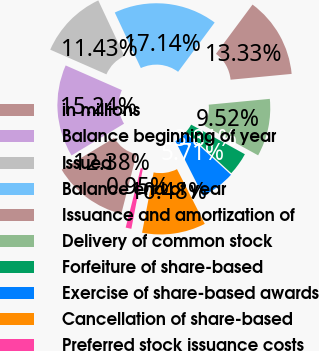Convert chart to OTSL. <chart><loc_0><loc_0><loc_500><loc_500><pie_chart><fcel>in millions<fcel>Balance beginning of year<fcel>Issued<fcel>Balance end of year<fcel>Issuance and amortization of<fcel>Delivery of common stock<fcel>Forfeiture of share-based<fcel>Exercise of share-based awards<fcel>Cancellation of share-based<fcel>Preferred stock issuance costs<nl><fcel>12.38%<fcel>15.24%<fcel>11.43%<fcel>17.14%<fcel>13.33%<fcel>9.52%<fcel>3.81%<fcel>5.71%<fcel>10.48%<fcel>0.95%<nl></chart> 